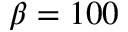<formula> <loc_0><loc_0><loc_500><loc_500>\beta = 1 0 0</formula> 